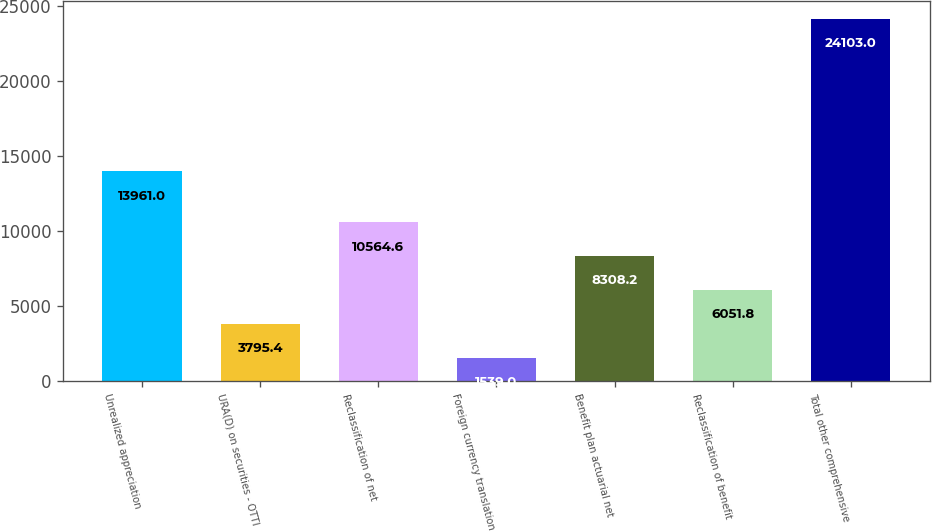Convert chart. <chart><loc_0><loc_0><loc_500><loc_500><bar_chart><fcel>Unrealized appreciation<fcel>URA(D) on securities - OTTI<fcel>Reclassification of net<fcel>Foreign currency translation<fcel>Benefit plan actuarial net<fcel>Reclassification of benefit<fcel>Total other comprehensive<nl><fcel>13961<fcel>3795.4<fcel>10564.6<fcel>1539<fcel>8308.2<fcel>6051.8<fcel>24103<nl></chart> 